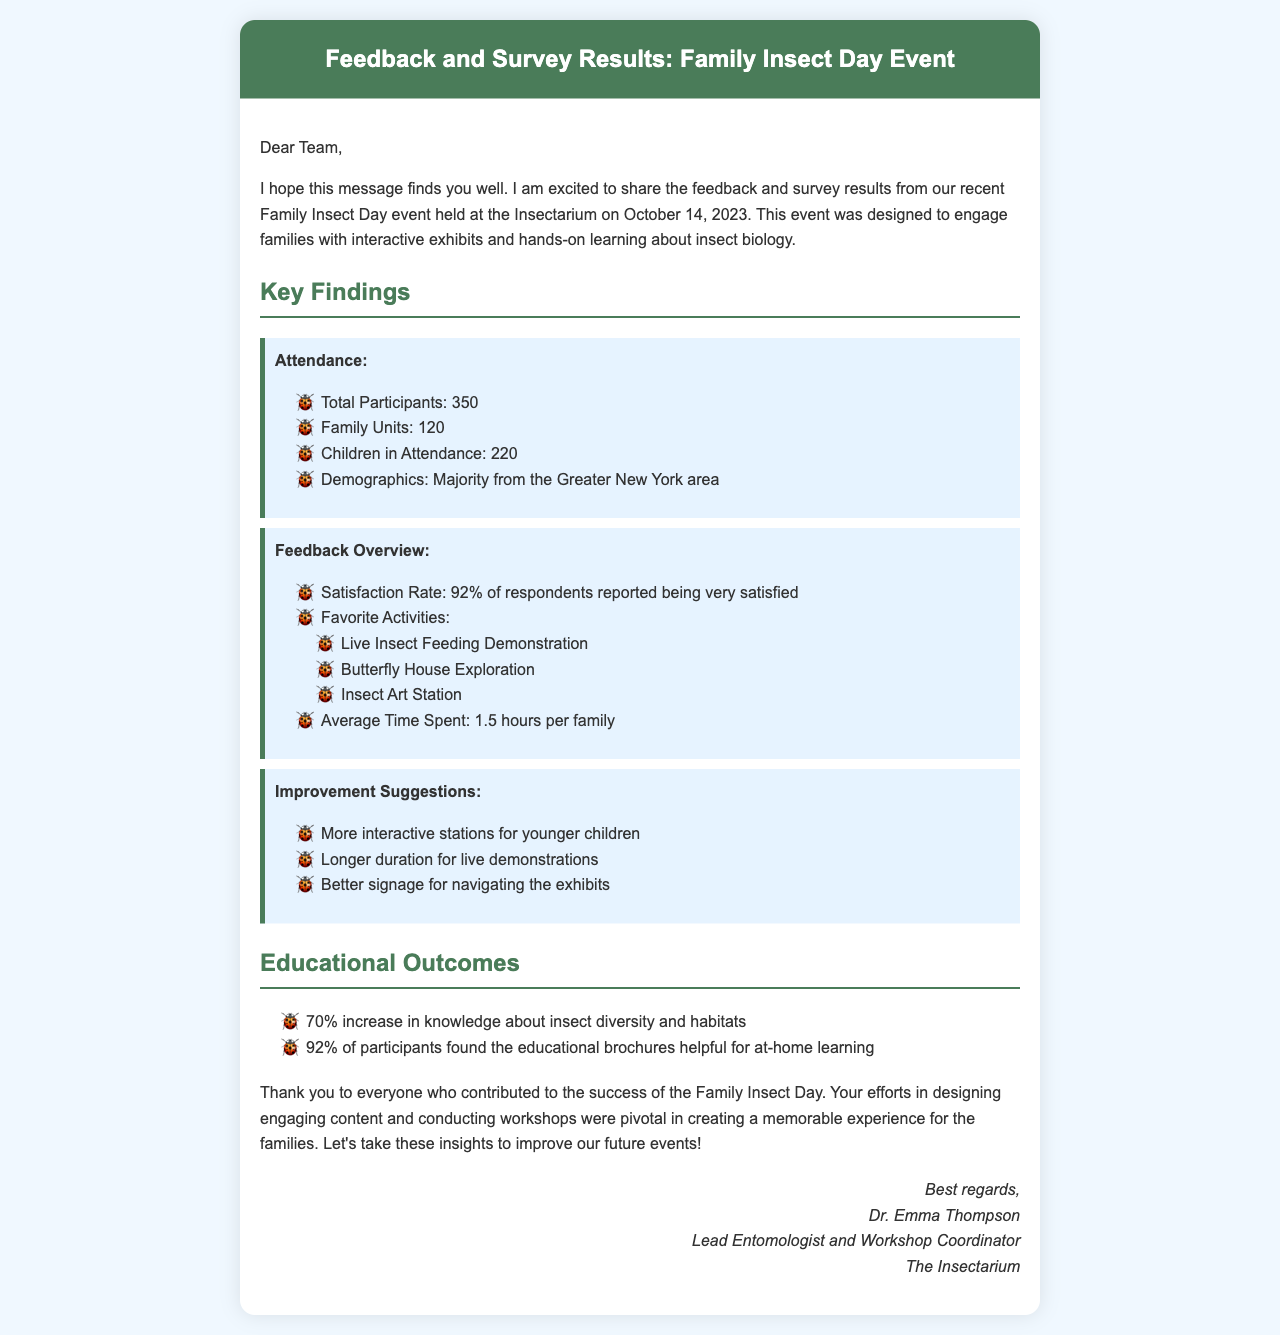What was the date of the event? The event took place on October 14, 2023, as mentioned in the opening paragraph.
Answer: October 14, 2023 How many total participants were there? The total number of participants is listed under the "Attendance" section.
Answer: 350 What percentage of respondents reported being very satisfied? The satisfaction rate is specifically mentioned in the "Feedback Overview" section.
Answer: 92% What was one of the favorite activities noted in the feedback? The favorite activities are listed in the "Feedback Overview," and any of them can be an answer.
Answer: Live Insect Feeding Demonstration What improvement suggestion was made regarding live demonstrations? The suggestion related to live demonstrations is found under the "Improvement Suggestions" section.
Answer: Longer duration for live demonstrations What percentage of participants found educational brochures helpful? The percentage is listed in the "Educational Outcomes" section.
Answer: 92% How long did families spend on average at the event? This information is found in the "Feedback Overview."
Answer: 1.5 hours Who is the sender of the email? The sender's name and title are included at the end of the email.
Answer: Dr. Emma Thompson What was the primary goal of the Family Insect Day event? The main goal is described in the opening paragraph as engaging families with interactive exhibits and hands-on learning.
Answer: Engage families with interactive exhibits and hands-on learning 